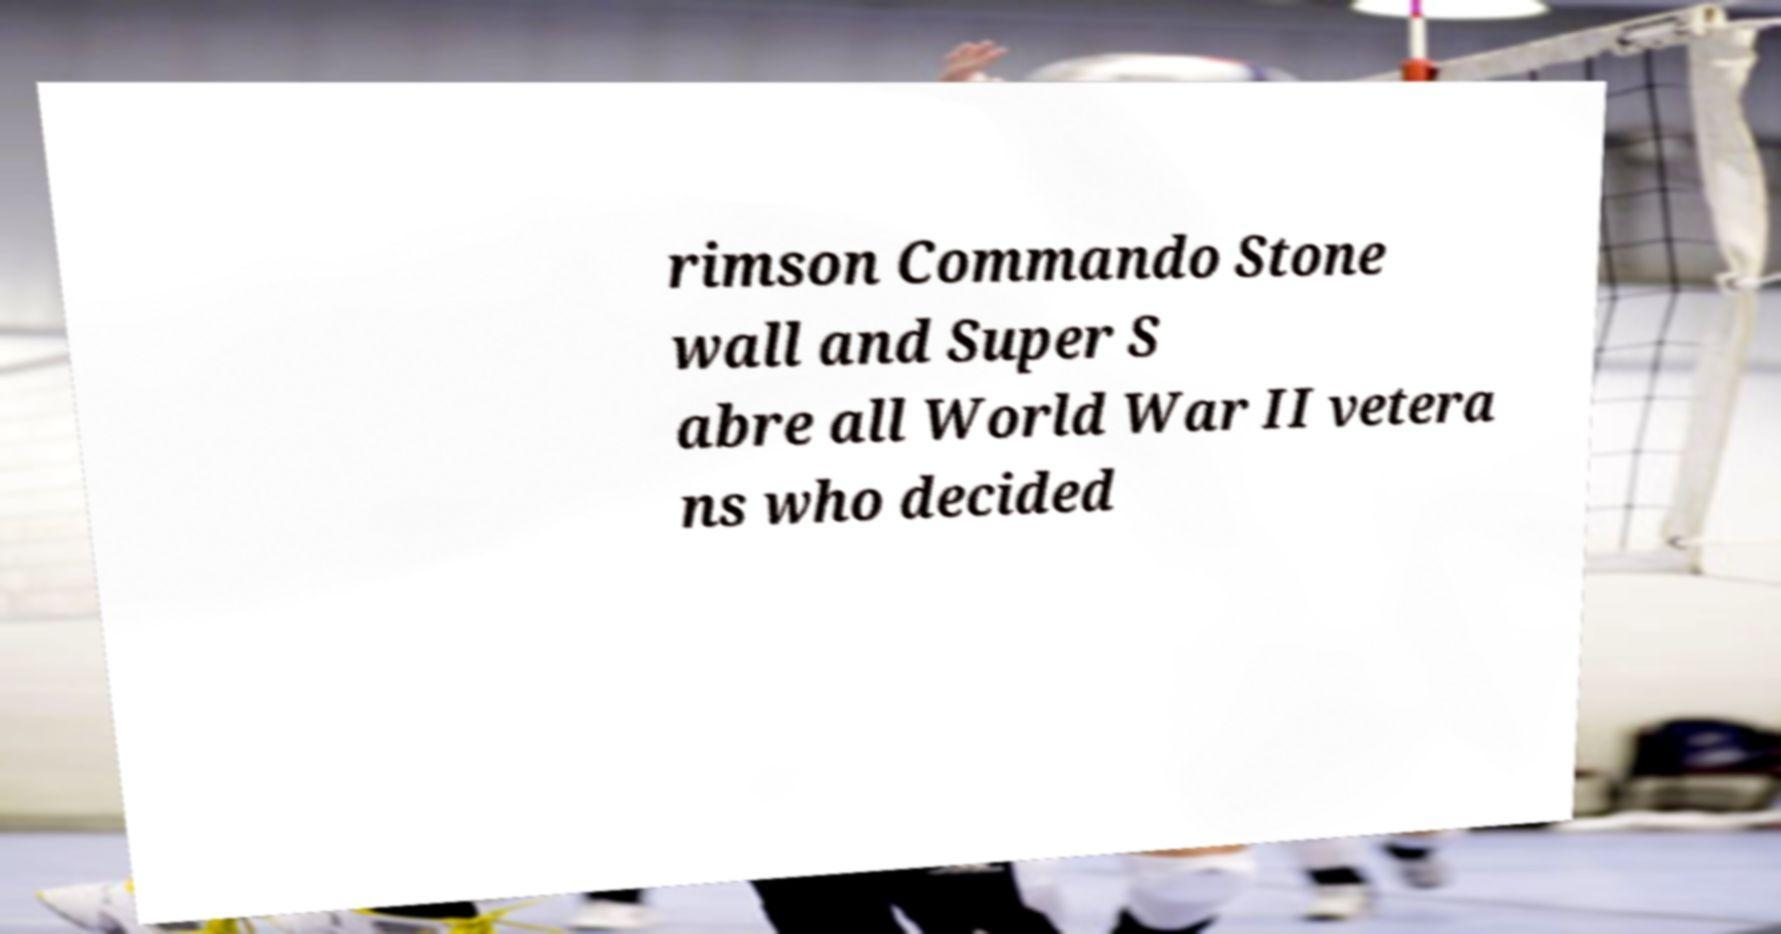Can you read and provide the text displayed in the image?This photo seems to have some interesting text. Can you extract and type it out for me? rimson Commando Stone wall and Super S abre all World War II vetera ns who decided 